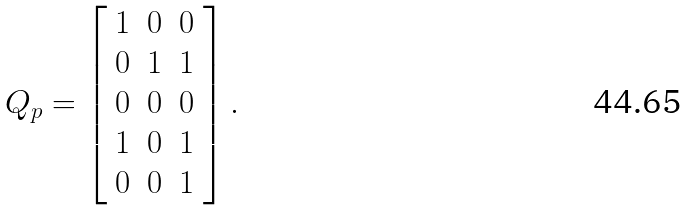<formula> <loc_0><loc_0><loc_500><loc_500>Q _ { p } = \left [ \begin{array} { c c c } 1 & 0 & 0 \\ 0 & 1 & 1 \\ 0 & 0 & 0 \\ 1 & 0 & 1 \\ 0 & 0 & 1 \end{array} \right ] .</formula> 